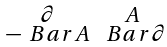Convert formula to latex. <formula><loc_0><loc_0><loc_500><loc_500>\begin{smallmatrix} \partial & A \\ - \ B a r { A } & \ B a r { \partial } \end{smallmatrix}</formula> 